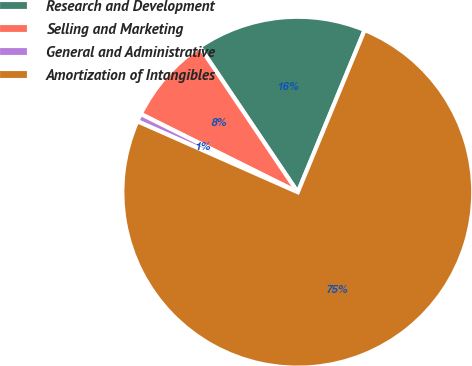Convert chart. <chart><loc_0><loc_0><loc_500><loc_500><pie_chart><fcel>Research and Development<fcel>Selling and Marketing<fcel>General and Administrative<fcel>Amortization of Intangibles<nl><fcel>15.67%<fcel>8.2%<fcel>0.73%<fcel>75.4%<nl></chart> 